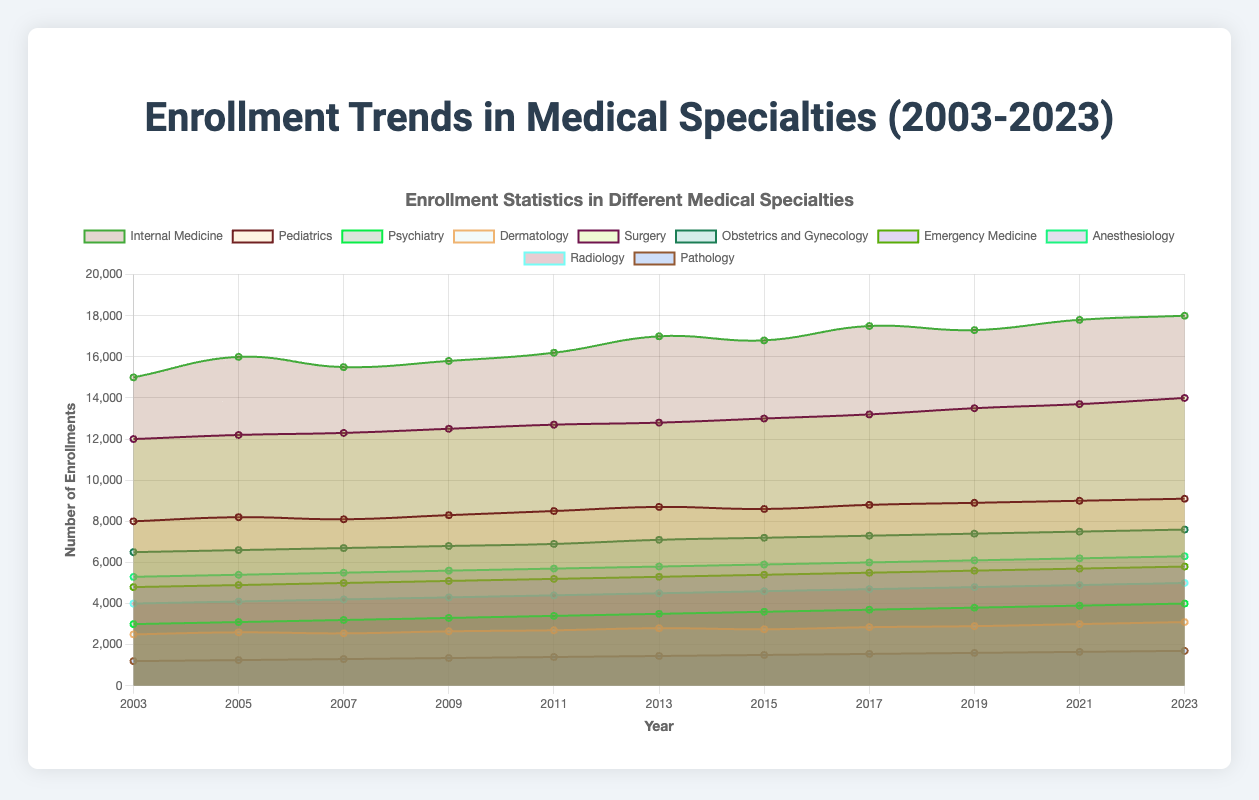What's the title of the chart? The title is located at the top of the chart. It gives a brief description of what the chart is about, which is "Enrollment Statistics in Different Medical Specialties Over the Last 20 Years."
Answer: Enrollment Statistics in Different Medical Specialties Over the Last 20 Years What are the years covered in the chart? The x-axis of the chart shows the range of years. We can see that it starts from the year 2003 and ends in the year 2023.
Answer: 2003 to 2023 Which medical specialty had the highest number of enrollments in 2023? By looking at the area filling and the labels at the top boundary in 2023 in the figure, Internal Medicine's area is the largest at the top in 2023.
Answer: Internal Medicine Which specialty has the lowest number of enrollments in 2003? Looking at the chart and identifying the colored areas at the bottom, Pathology has the smallest area at the start year of 2003.
Answer: Pathology What is the trend of enrollments in Psychiatry over the years? Examine the trend line for Psychiatry from 2003 to 2023. Observe that it starts at 3000 and increases steadily every year until it reaches 4000 in 2023.
Answer: Steadily increasing How much did the total number of enrollments for Surgery change from 2003 to 2023? Looking at the data points for Surgery, in 2003 it was 12000 and in 2023 it is 14000. The change is calculated as 14000 - 12000.
Answer: 2000 Which specialty has seen the most consistent increase in enrollments over the years? By observing the chart and looking at the specialties that have a consistent upwards trend without significant fluctuations, Psychiatry shows a consistent increase from 3000 in 2003 to 4000 in 2023.
Answer: Psychiatry Which two specialties have a similar number of enrollments in 2023? By examining the chart closely for 2023, Pediatrics and Obstetrics and Gynecology both have enrollments around 9100 and 7600, respectively, which are somewhat close to each other compared to other specialties.
Answer: Pediatrics and Obstetrics and Gynecology What is the difference in enrollments between Internal Medicine and Dermatology in 2021? Check the enrollment numbers for Internal Medicine and Dermatology in the year 2021. Internal Medicine has around 17800 and Dermatology has around 3000. The difference is 17800 - 3000.
Answer: 14800 Which specialty has seen the least growth in enrollments from 2003 to 2023? By comparing the starting and ending values of each specialty from 2003 to 2023, Pathology starts at 1200 and ends at 1700, showing the least growth among all specialties.
Answer: Pathology 